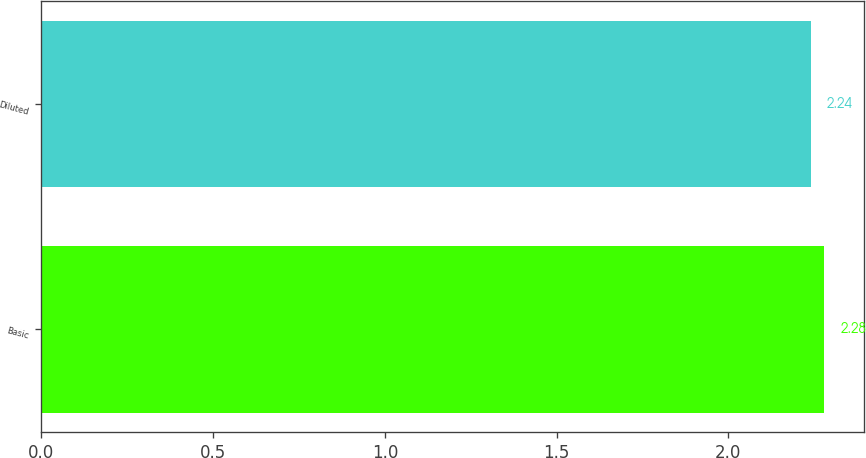Convert chart to OTSL. <chart><loc_0><loc_0><loc_500><loc_500><bar_chart><fcel>Basic<fcel>Diluted<nl><fcel>2.28<fcel>2.24<nl></chart> 